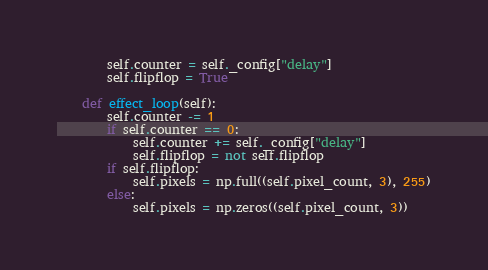<code> <loc_0><loc_0><loc_500><loc_500><_Python_>        self.counter = self._config["delay"]
        self.flipflop = True

    def effect_loop(self):
        self.counter -= 1
        if self.counter == 0:
            self.counter += self._config["delay"]
            self.flipflop = not self.flipflop
        if self.flipflop:
            self.pixels = np.full((self.pixel_count, 3), 255)
        else:
            self.pixels = np.zeros((self.pixel_count, 3))

</code> 